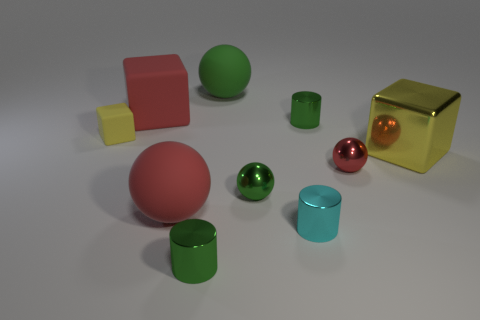Subtract all cylinders. How many objects are left? 7 Add 6 big yellow things. How many big yellow things exist? 7 Subtract 0 blue balls. How many objects are left? 10 Subtract all small matte cylinders. Subtract all big red matte spheres. How many objects are left? 9 Add 2 tiny green metal things. How many tiny green metal things are left? 5 